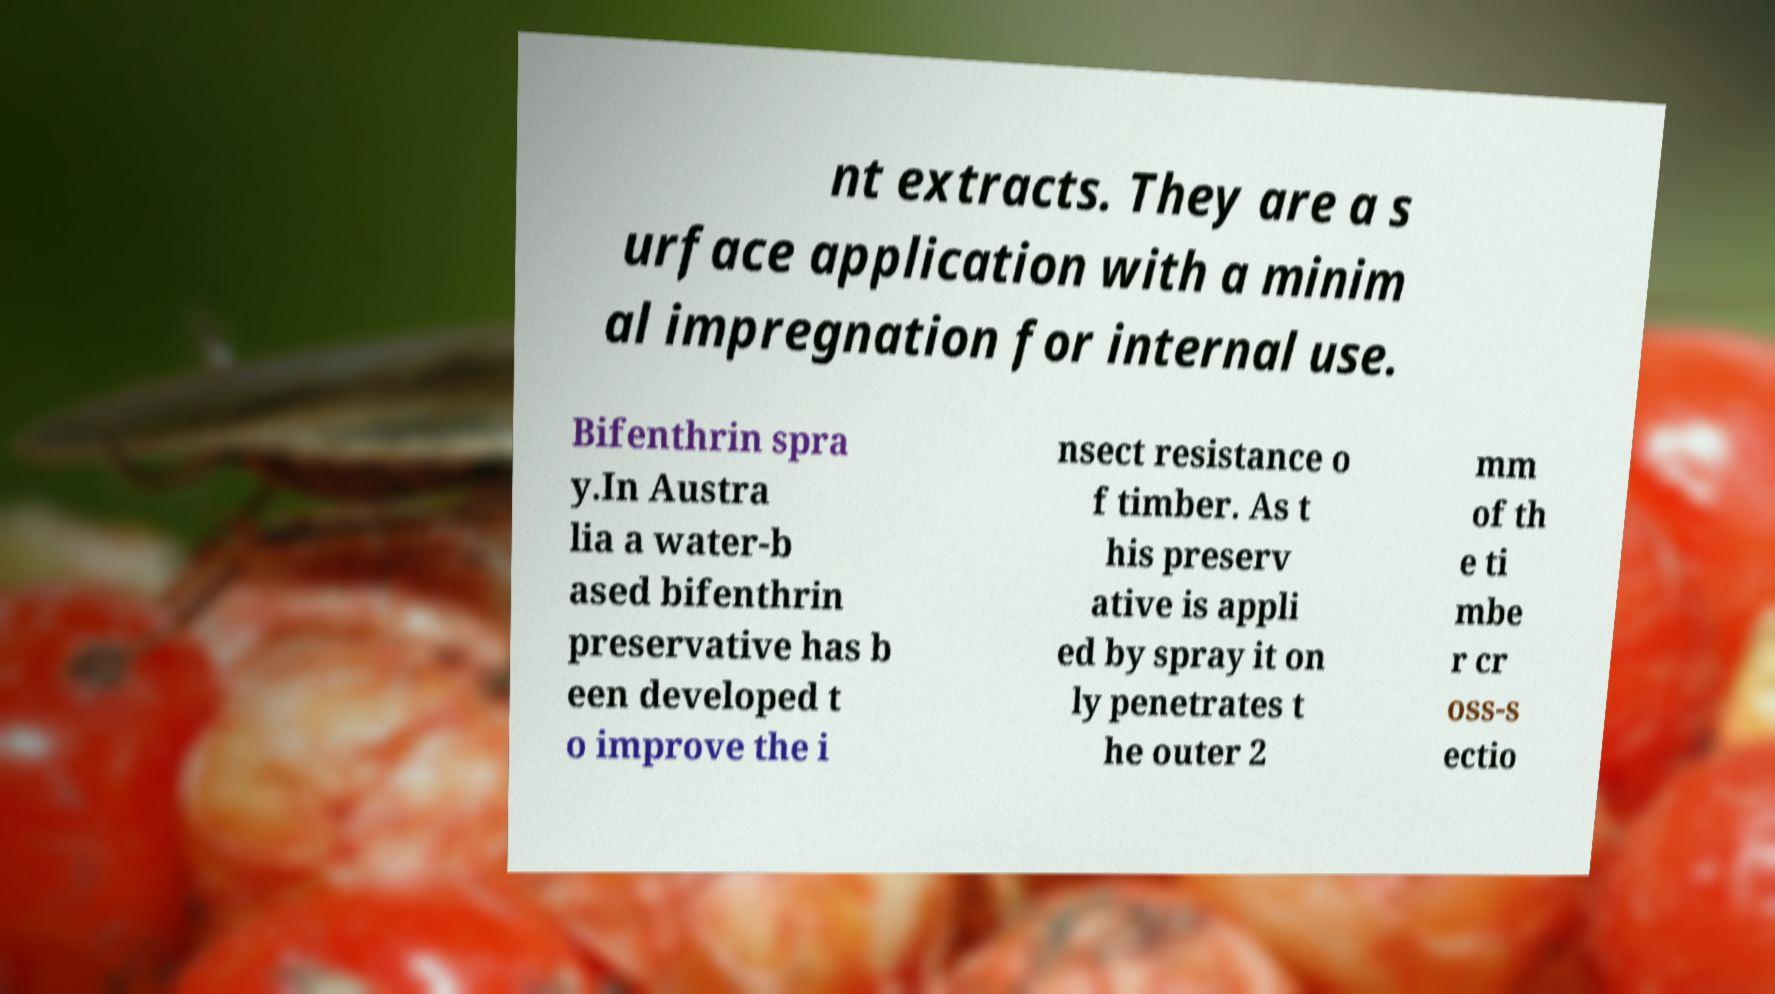What messages or text are displayed in this image? I need them in a readable, typed format. nt extracts. They are a s urface application with a minim al impregnation for internal use. Bifenthrin spra y.In Austra lia a water-b ased bifenthrin preservative has b een developed t o improve the i nsect resistance o f timber. As t his preserv ative is appli ed by spray it on ly penetrates t he outer 2 mm of th e ti mbe r cr oss-s ectio 